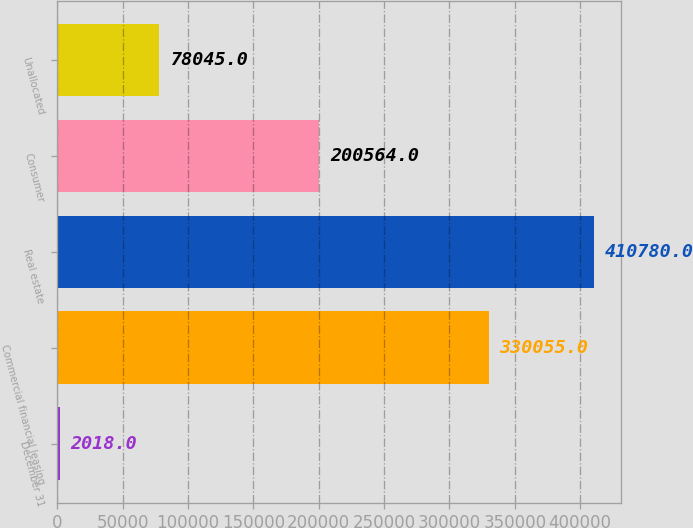<chart> <loc_0><loc_0><loc_500><loc_500><bar_chart><fcel>December 31<fcel>Commercial financial leasing<fcel>Real estate<fcel>Consumer<fcel>Unallocated<nl><fcel>2018<fcel>330055<fcel>410780<fcel>200564<fcel>78045<nl></chart> 